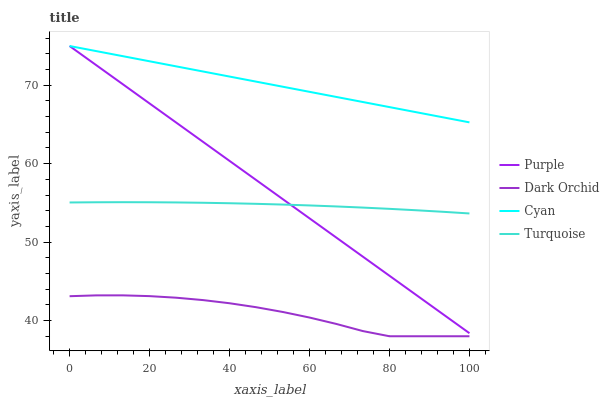Does Dark Orchid have the minimum area under the curve?
Answer yes or no. Yes. Does Cyan have the maximum area under the curve?
Answer yes or no. Yes. Does Turquoise have the minimum area under the curve?
Answer yes or no. No. Does Turquoise have the maximum area under the curve?
Answer yes or no. No. Is Cyan the smoothest?
Answer yes or no. Yes. Is Dark Orchid the roughest?
Answer yes or no. Yes. Is Turquoise the smoothest?
Answer yes or no. No. Is Turquoise the roughest?
Answer yes or no. No. Does Dark Orchid have the lowest value?
Answer yes or no. Yes. Does Turquoise have the lowest value?
Answer yes or no. No. Does Cyan have the highest value?
Answer yes or no. Yes. Does Turquoise have the highest value?
Answer yes or no. No. Is Dark Orchid less than Cyan?
Answer yes or no. Yes. Is Cyan greater than Dark Orchid?
Answer yes or no. Yes. Does Turquoise intersect Purple?
Answer yes or no. Yes. Is Turquoise less than Purple?
Answer yes or no. No. Is Turquoise greater than Purple?
Answer yes or no. No. Does Dark Orchid intersect Cyan?
Answer yes or no. No. 